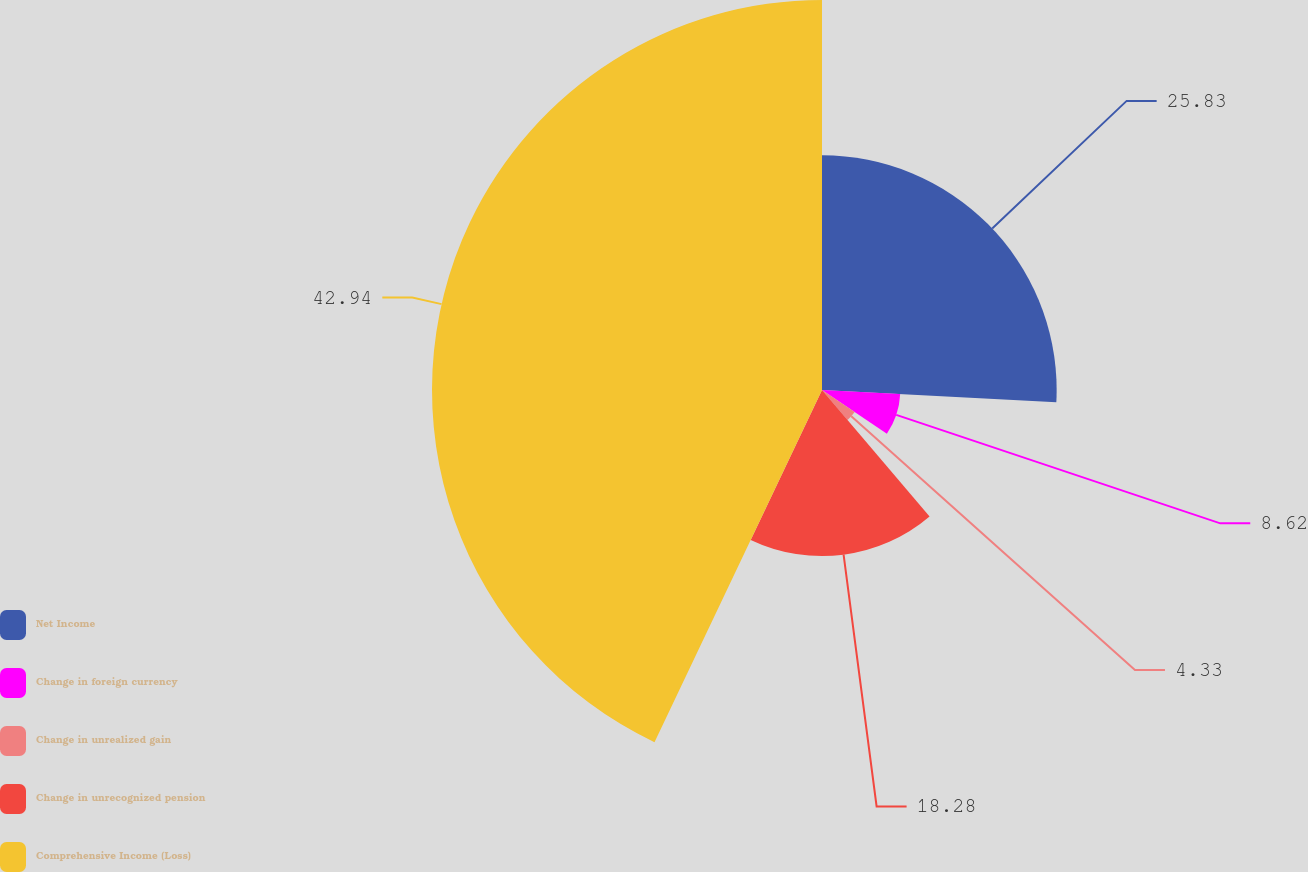Convert chart. <chart><loc_0><loc_0><loc_500><loc_500><pie_chart><fcel>Net Income<fcel>Change in foreign currency<fcel>Change in unrealized gain<fcel>Change in unrecognized pension<fcel>Comprehensive Income (Loss)<nl><fcel>25.83%<fcel>8.62%<fcel>4.33%<fcel>18.28%<fcel>42.93%<nl></chart> 